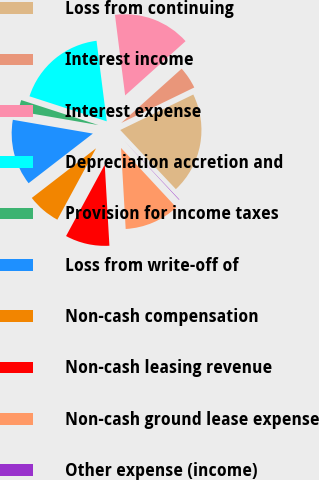Convert chart to OTSL. <chart><loc_0><loc_0><loc_500><loc_500><pie_chart><fcel>Loss from continuing<fcel>Interest income<fcel>Interest expense<fcel>Depreciation accretion and<fcel>Provision for income taxes<fcel>Loss from write-off of<fcel>Non-cash compensation<fcel>Non-cash leasing revenue<fcel>Non-cash ground lease expense<fcel>Other expense (income)<nl><fcel>20.19%<fcel>4.45%<fcel>15.36%<fcel>18.01%<fcel>2.27%<fcel>13.18%<fcel>6.63%<fcel>8.82%<fcel>11.0%<fcel>0.09%<nl></chart> 